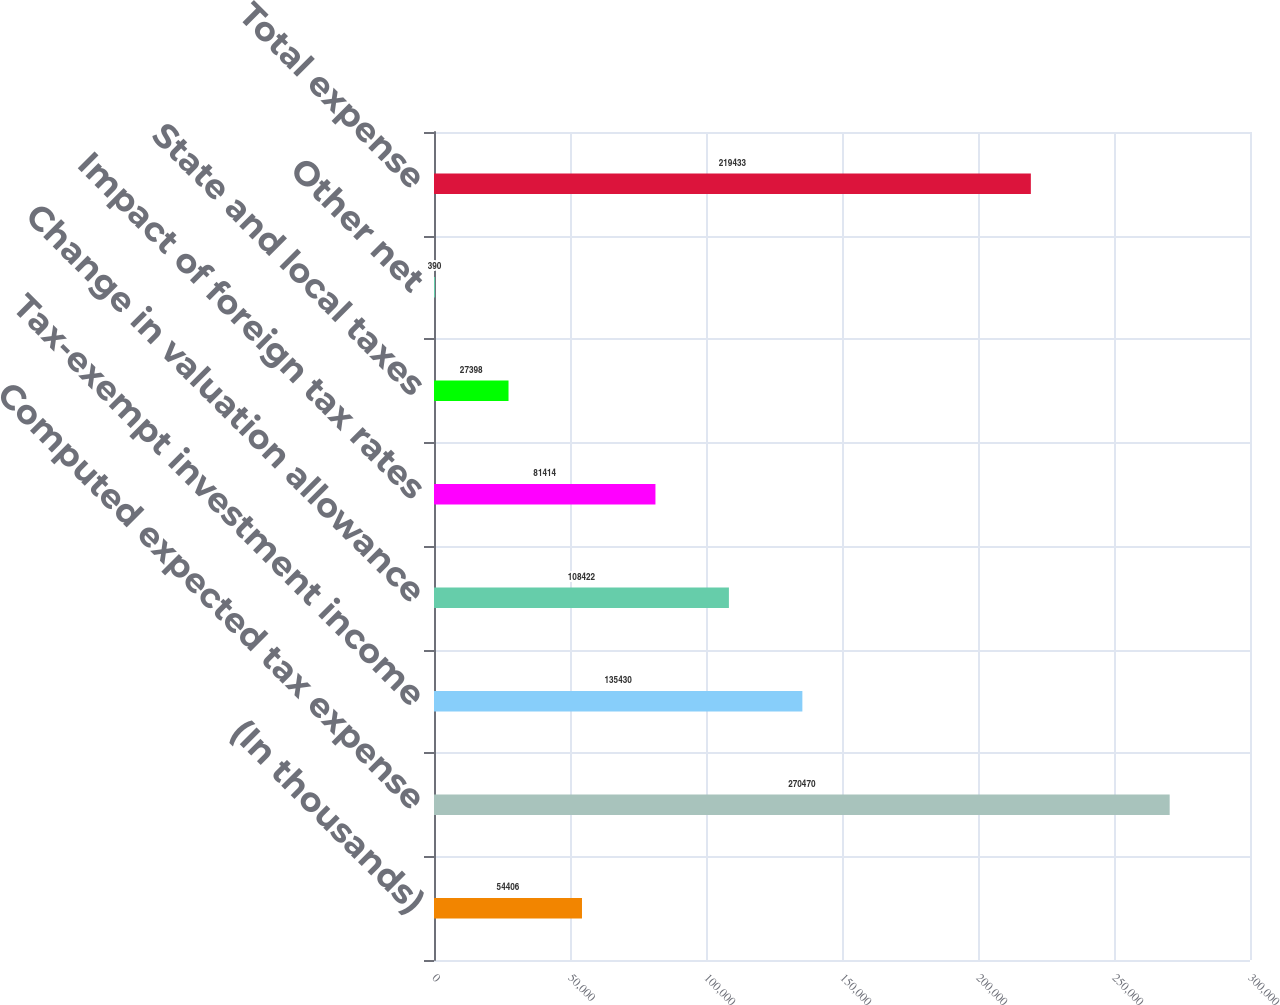<chart> <loc_0><loc_0><loc_500><loc_500><bar_chart><fcel>(In thousands)<fcel>Computed expected tax expense<fcel>Tax-exempt investment income<fcel>Change in valuation allowance<fcel>Impact of foreign tax rates<fcel>State and local taxes<fcel>Other net<fcel>Total expense<nl><fcel>54406<fcel>270470<fcel>135430<fcel>108422<fcel>81414<fcel>27398<fcel>390<fcel>219433<nl></chart> 